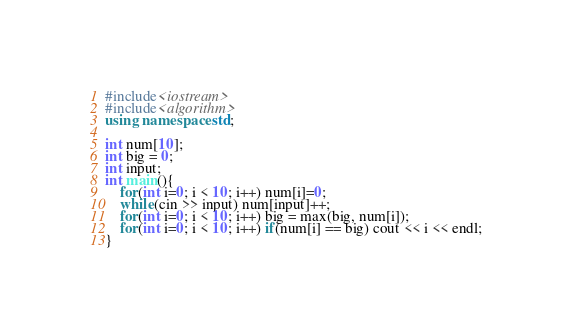<code> <loc_0><loc_0><loc_500><loc_500><_C++_>#include<iostream>
#include<algorithm>
using namespace std;

int num[10];
int big = 0;
int input;
int main(){
	for(int i=0; i < 10; i++) num[i]=0;
	while(cin >> input) num[input]++;
	for(int i=0; i < 10; i++) big = max(big, num[i]);
	for(int i=0; i < 10; i++) if(num[i] == big) cout << i << endl;
}</code> 